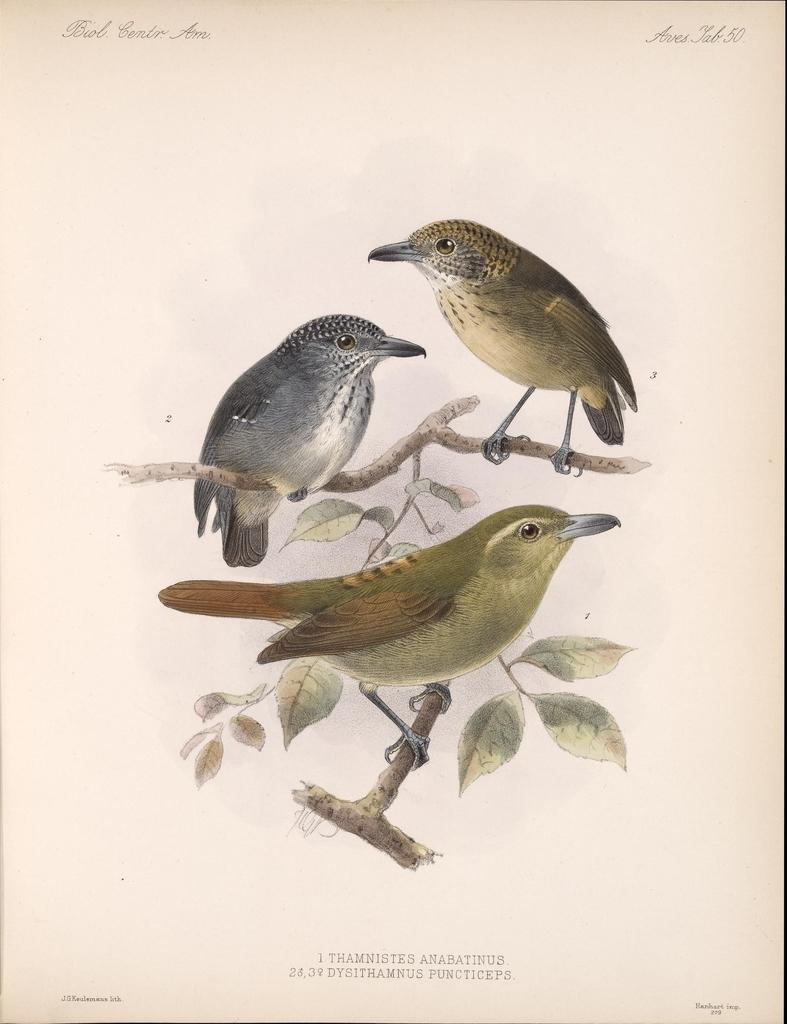What is the main subject of the paper in the image? The paper contains pictures of birds, branches, and leaves. Can you describe the content of the pictures on the paper? The pictures on the paper include birds, branches, and leaves. Where is the writing located on the paper in the image? There is writing at the top and bottom of the image. What type of stocking is visible on the front of the paper in the image? There is no stocking visible on the front of the paper in the image. Is there a party happening in the image? There is no indication of a party in the image, as it only features a paper with pictures and writing. 